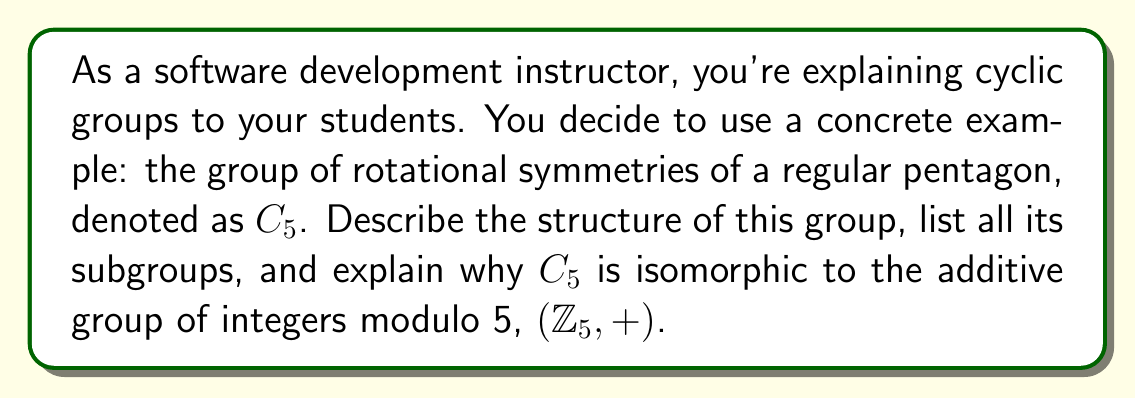Provide a solution to this math problem. Let's break this down step-by-step:

1) Structure of $C_5$:
   $C_5$ consists of rotations by multiples of 72° (360°/5). Let $r$ represent a rotation by 72°.
   The elements of $C_5$ are: $\{e, r, r^2, r^3, r^4\}$, where $e$ is the identity (rotation by 0° or 360°).
   The group operation is composition of rotations.

2) Properties of $C_5$:
   - It's cyclic: all elements can be generated by powers of $r$.
   - It's abelian: $r^i r^j = r^j r^i$ for all $i,j$.
   - The order of the group is 5.
   - The order of each non-identity element is also 5.

3) Subgroups of $C_5$:
   By Lagrange's theorem, the order of a subgroup must divide the order of the group.
   The only divisors of 5 are 1 and 5. Therefore, $C_5$ has only two subgroups:
   - The trivial subgroup $\{e\}$
   - The entire group $C_5$ itself

4) Isomorphism to $(\mathbb{Z}_5, +)$:
   We can establish an isomorphism $\phi: C_5 \to (\mathbb{Z}_5, +)$ as follows:
   $\phi(e) = 0$
   $\phi(r) = 1$
   $\phi(r^2) = 2$
   $\phi(r^3) = 3$
   $\phi(r^4) = 4$

   This mapping preserves the group operation:
   $\phi(r^i \cdot r^j) = \phi(r^{i+j \mod 5}) = (i+j) \mod 5 = \phi(r^i) + \phi(r^j)$

   It's bijective (one-to-one and onto), so it's an isomorphism.

This example demonstrates key properties of cyclic groups:
- They're generated by a single element.
- Their subgroups are also cyclic.
- The number of elements of order $d$ in a cyclic group of order $n$ is $\phi(d)$ if $d|n$, and 0 otherwise, where $\phi$ is Euler's totient function.
- All cyclic groups of the same order are isomorphic.
Answer: The group $C_5$ has 5 elements $\{e, r, r^2, r^3, r^4\}$, where $r$ represents a rotation by 72°. It has only two subgroups: $\{e\}$ and $C_5$ itself. $C_5$ is isomorphic to $(\mathbb{Z}_5, +)$ via the mapping $\phi(r^k) = k \mod 5$. 